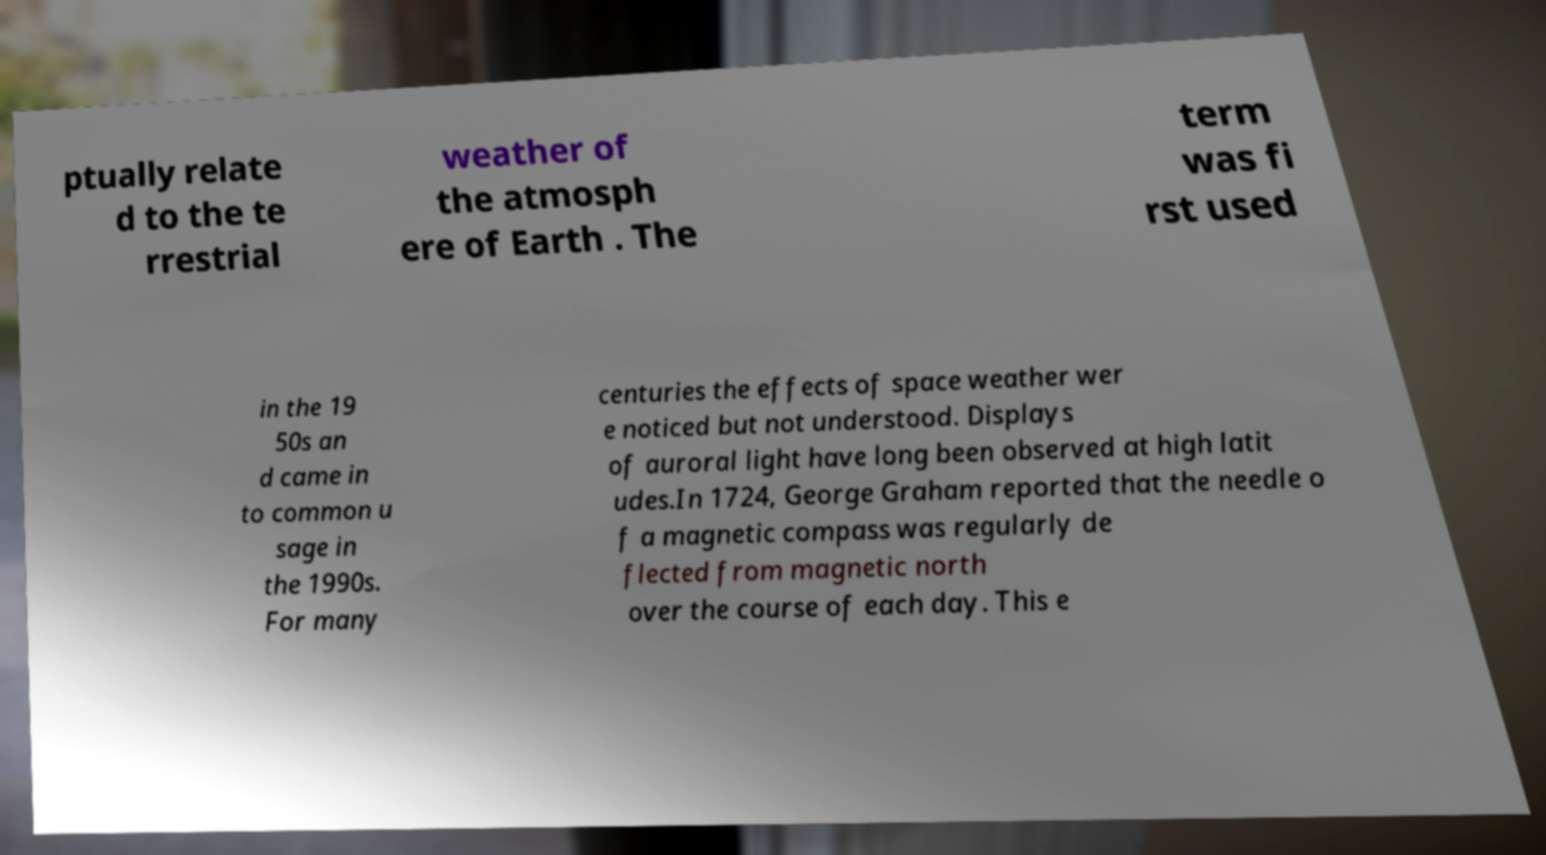Please read and relay the text visible in this image. What does it say? ptually relate d to the te rrestrial weather of the atmosph ere of Earth . The term was fi rst used in the 19 50s an d came in to common u sage in the 1990s. For many centuries the effects of space weather wer e noticed but not understood. Displays of auroral light have long been observed at high latit udes.In 1724, George Graham reported that the needle o f a magnetic compass was regularly de flected from magnetic north over the course of each day. This e 